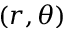Convert formula to latex. <formula><loc_0><loc_0><loc_500><loc_500>( r , \theta )</formula> 